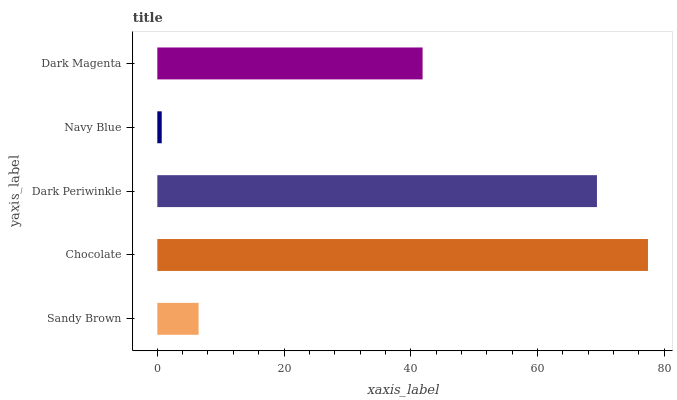Is Navy Blue the minimum?
Answer yes or no. Yes. Is Chocolate the maximum?
Answer yes or no. Yes. Is Dark Periwinkle the minimum?
Answer yes or no. No. Is Dark Periwinkle the maximum?
Answer yes or no. No. Is Chocolate greater than Dark Periwinkle?
Answer yes or no. Yes. Is Dark Periwinkle less than Chocolate?
Answer yes or no. Yes. Is Dark Periwinkle greater than Chocolate?
Answer yes or no. No. Is Chocolate less than Dark Periwinkle?
Answer yes or no. No. Is Dark Magenta the high median?
Answer yes or no. Yes. Is Dark Magenta the low median?
Answer yes or no. Yes. Is Chocolate the high median?
Answer yes or no. No. Is Chocolate the low median?
Answer yes or no. No. 